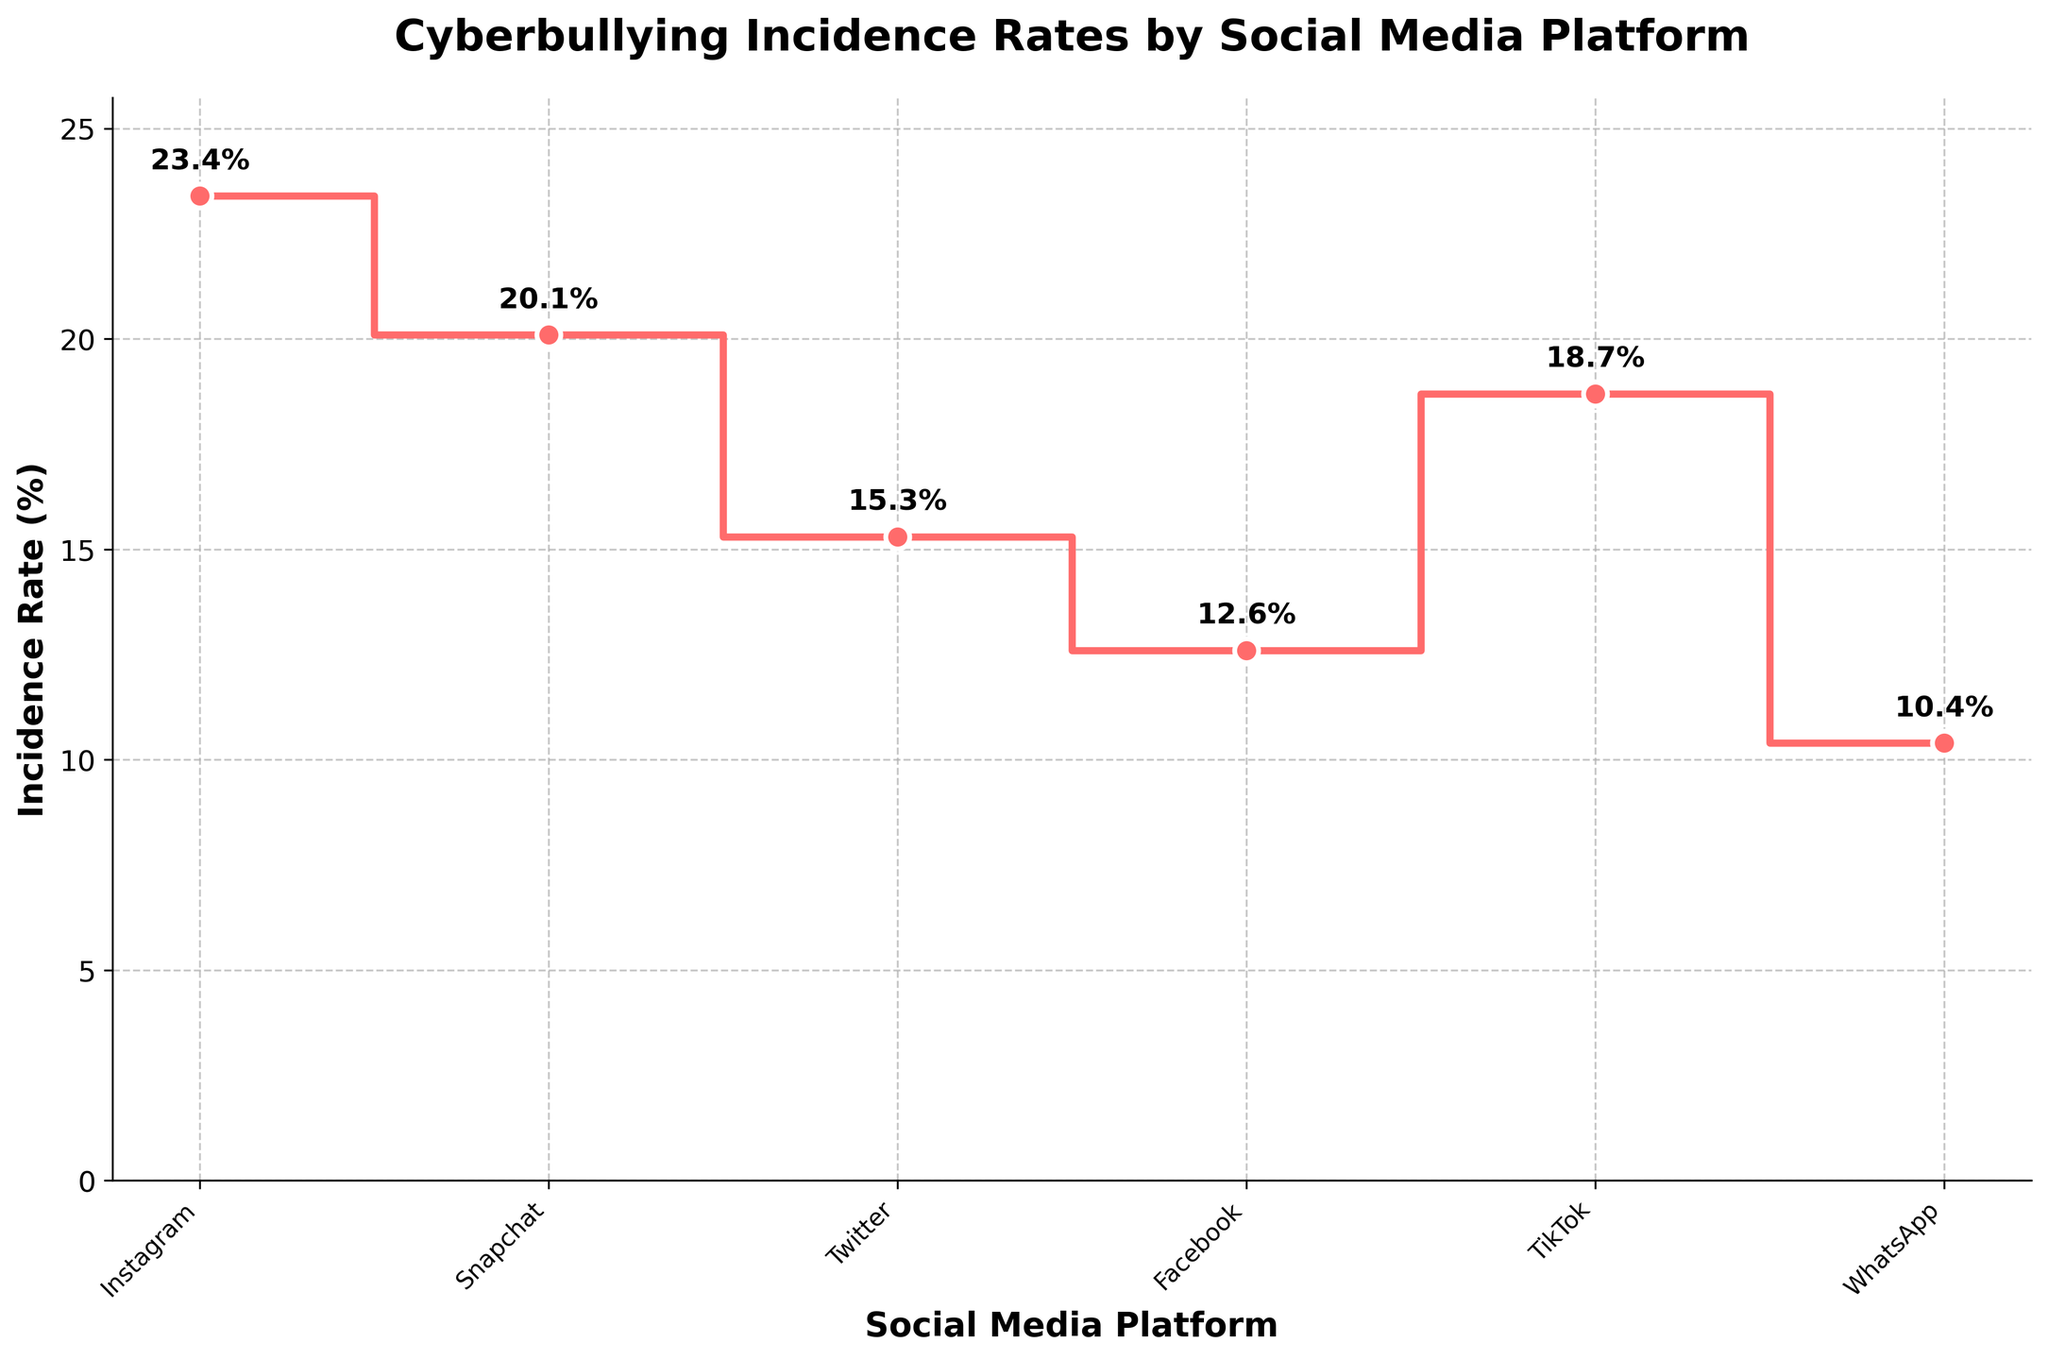What is the title of the figure? The title is located at the top center of the figure and is meant to describe what the plot represents.
Answer: Cyberbullying Incidence Rates by Social Media Platform Which social media platform has the highest incidence rate of cyberbullying? The incidence rate values are provided directly in the figure next to the data points. By looking at the highest value, we can find the corresponding platform.
Answer: Instagram What is the incidence rate of cyberbullying on TikTok? By checking the plotted data points and the labels next to them, we can identify the rate for TikTok.
Answer: 18.7% What is the difference in incidence rates between Instagram and WhatsApp? Identify the incidence rates for both Instagram (23.4) and WhatsApp (10.4) from the figure, then subtract the smaller rate from the larger rate.
Answer: 13.0 Which platform has a lower incidence rate of cyberbullying: Snapchat or Facebook? Compare the incidence rate values for Snapchat (20.1) and Facebook (12.6). The one with the smaller value has the lower rate.
Answer: Facebook What is the average incidence rate of cyberbullying across all the platforms shown? Sum all the incidence rate values and divide by the number of platforms: (23.4 + 20.1 + 15.3 + 12.6 + 18.7 + 10.4) / 6.
Answer: 16.75% How much higher is the incidence rate on Twitter compared to WhatsApp? Identify the incidence rates for Twitter (15.3) and WhatsApp (10.4) and then subtract the WhatsApp value from the Twitter value.
Answer: 4.9 Which platform shows the second highest incidence rate of cyberbullying? List the incidence rates in descending order: 23.4, 20.1, 18.7… The second highest value corresponds to the platform with the second highest rate.
Answer: Snapchat What range of incidence rates is depicted in the figure? Identify and calculate the difference between the highest incidence rate (Instagram: 23.4%) and the lowest incidence rate (WhatsApp: 10.4%).
Answer: 13.0% Is the incidence rate higher on TikTok or Facebook? Compare the incidence rate values for TikTok (18.7%) and Facebook (12.6%). The one with the larger value has the higher rate.
Answer: TikTok 